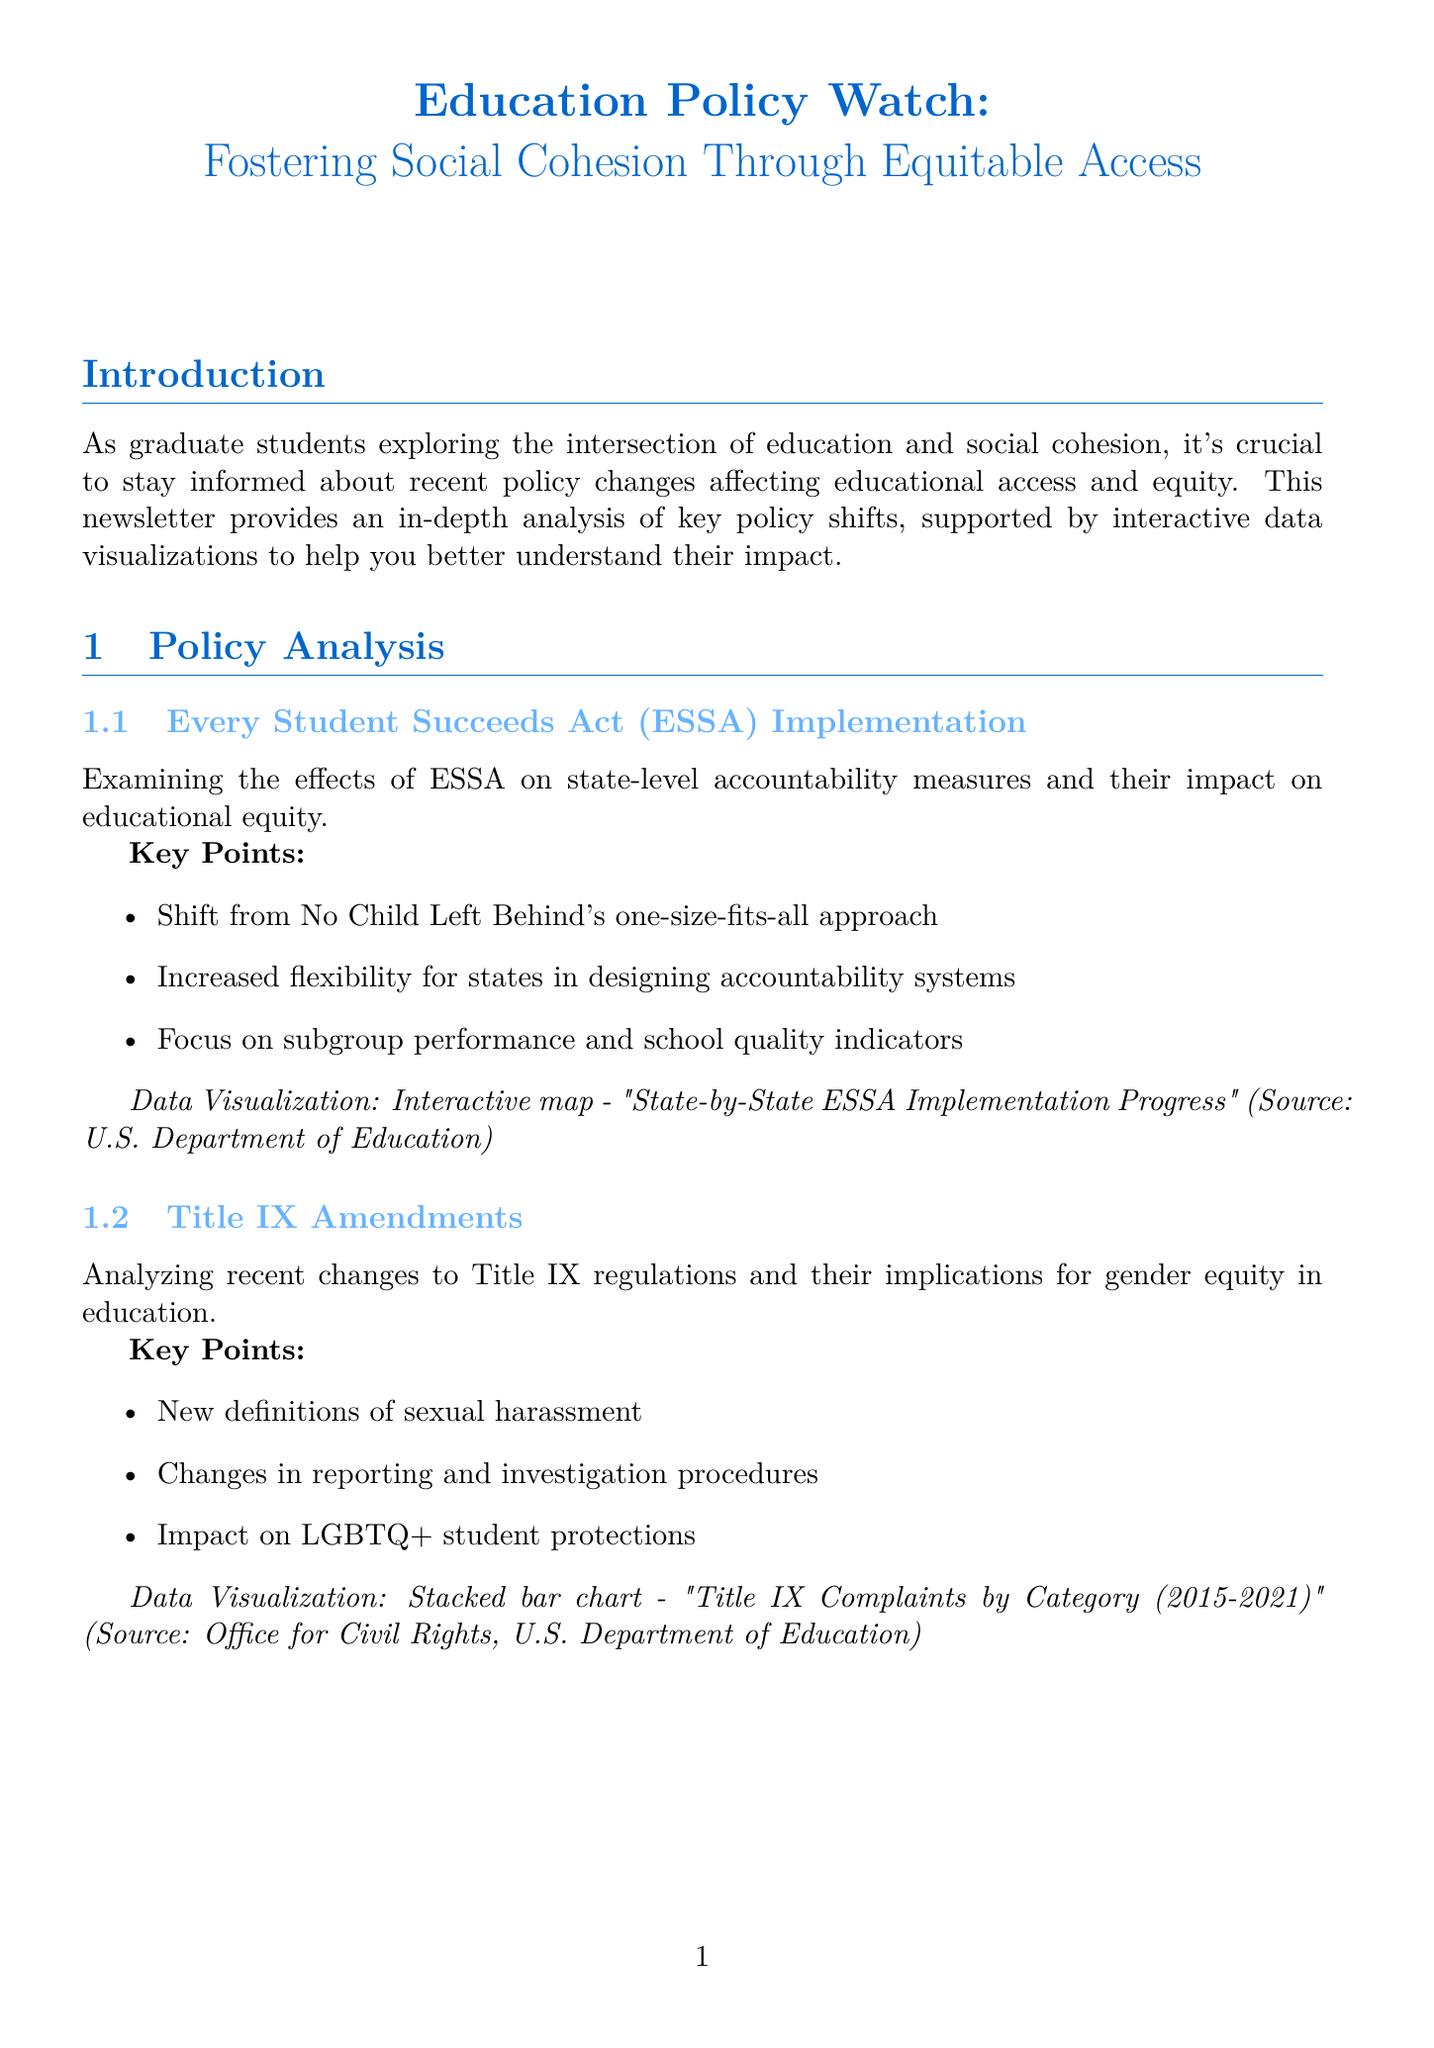What is the title of the newsletter? The title of the newsletter is clearly stated at the top of the document.
Answer: Education Policy Watch: Fostering Social Cohesion Through Equitable Access Who is the expert interviewed in the newsletter? The expert's name is mentioned in the expert interview section of the document.
Answer: Dr. Linda Darling-Hammond What does ESSA stand for? The abbreviation for the policy discussed is provided in the document.
Answer: Every Student Succeeds Act What type of data visualization is used for Title IX complaints? The type of data visualization is specified in the Title IX Amendments section.
Answer: Stacked bar chart What are the dates of the AERA Annual Meeting? The dates of the event are detailed in the upcoming events section.
Answer: April 13-16, 2023 What is one key point about school choice expansion? Key points are summarized in each policy analysis section of the document.
Answer: Growth of charter schools and voucher programs Which publication did Linda Darling-Hammond author? The recommended readings section lists authors and titles of important literature.
Answer: The Flat World and Education: How America's Commitment to Equity Will Determine Our Future What is the purpose of the Educational Equity Research Project? The call to action section describes the initiative's goals.
Answer: Examining the impact of recent policy changes on educational access and social cohesion 